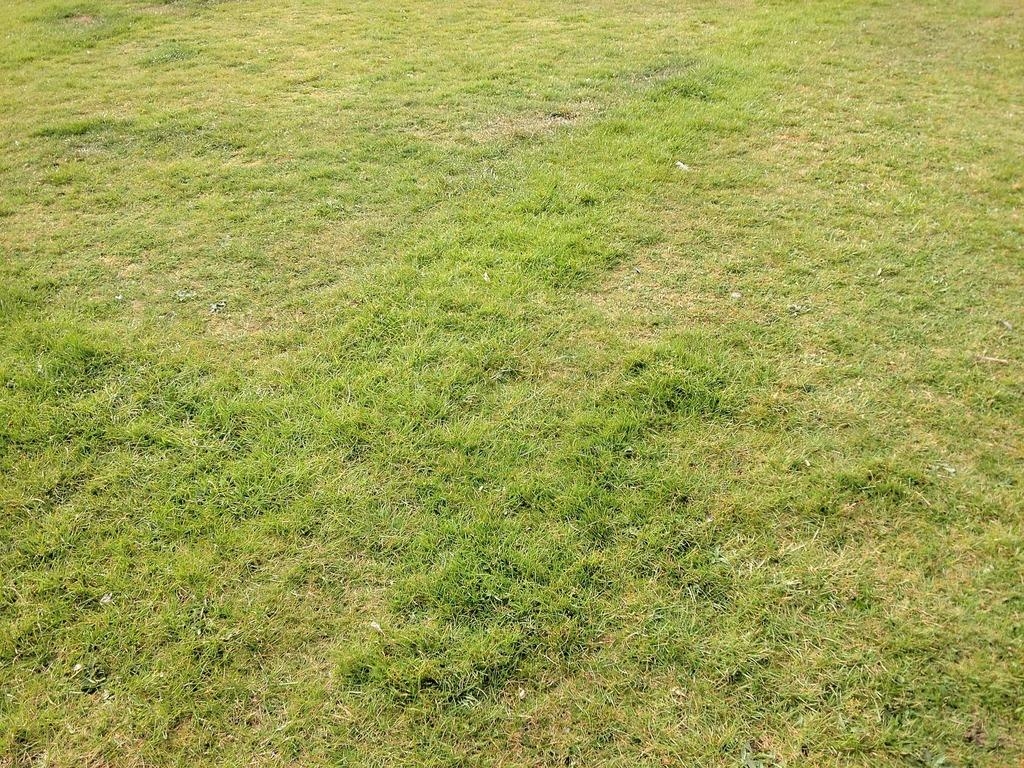What type of vegetation is visible on the ground in the image? There is green grass on the ground in the image. How many eggs are in the jar in the image? There is no jar or eggs present in the image; it only features green grass on the ground. 